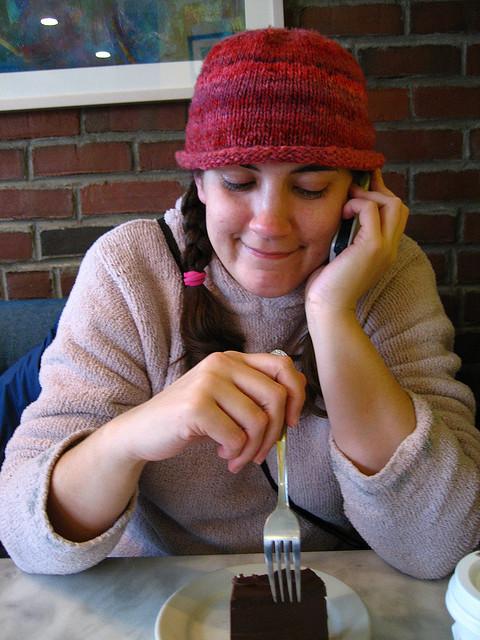Is the girl wearing a hat?
Keep it brief. Yes. Is the girl eating cake?
Quick response, please. Yes. Is this girl enjoying the conversation?
Give a very brief answer. Yes. 